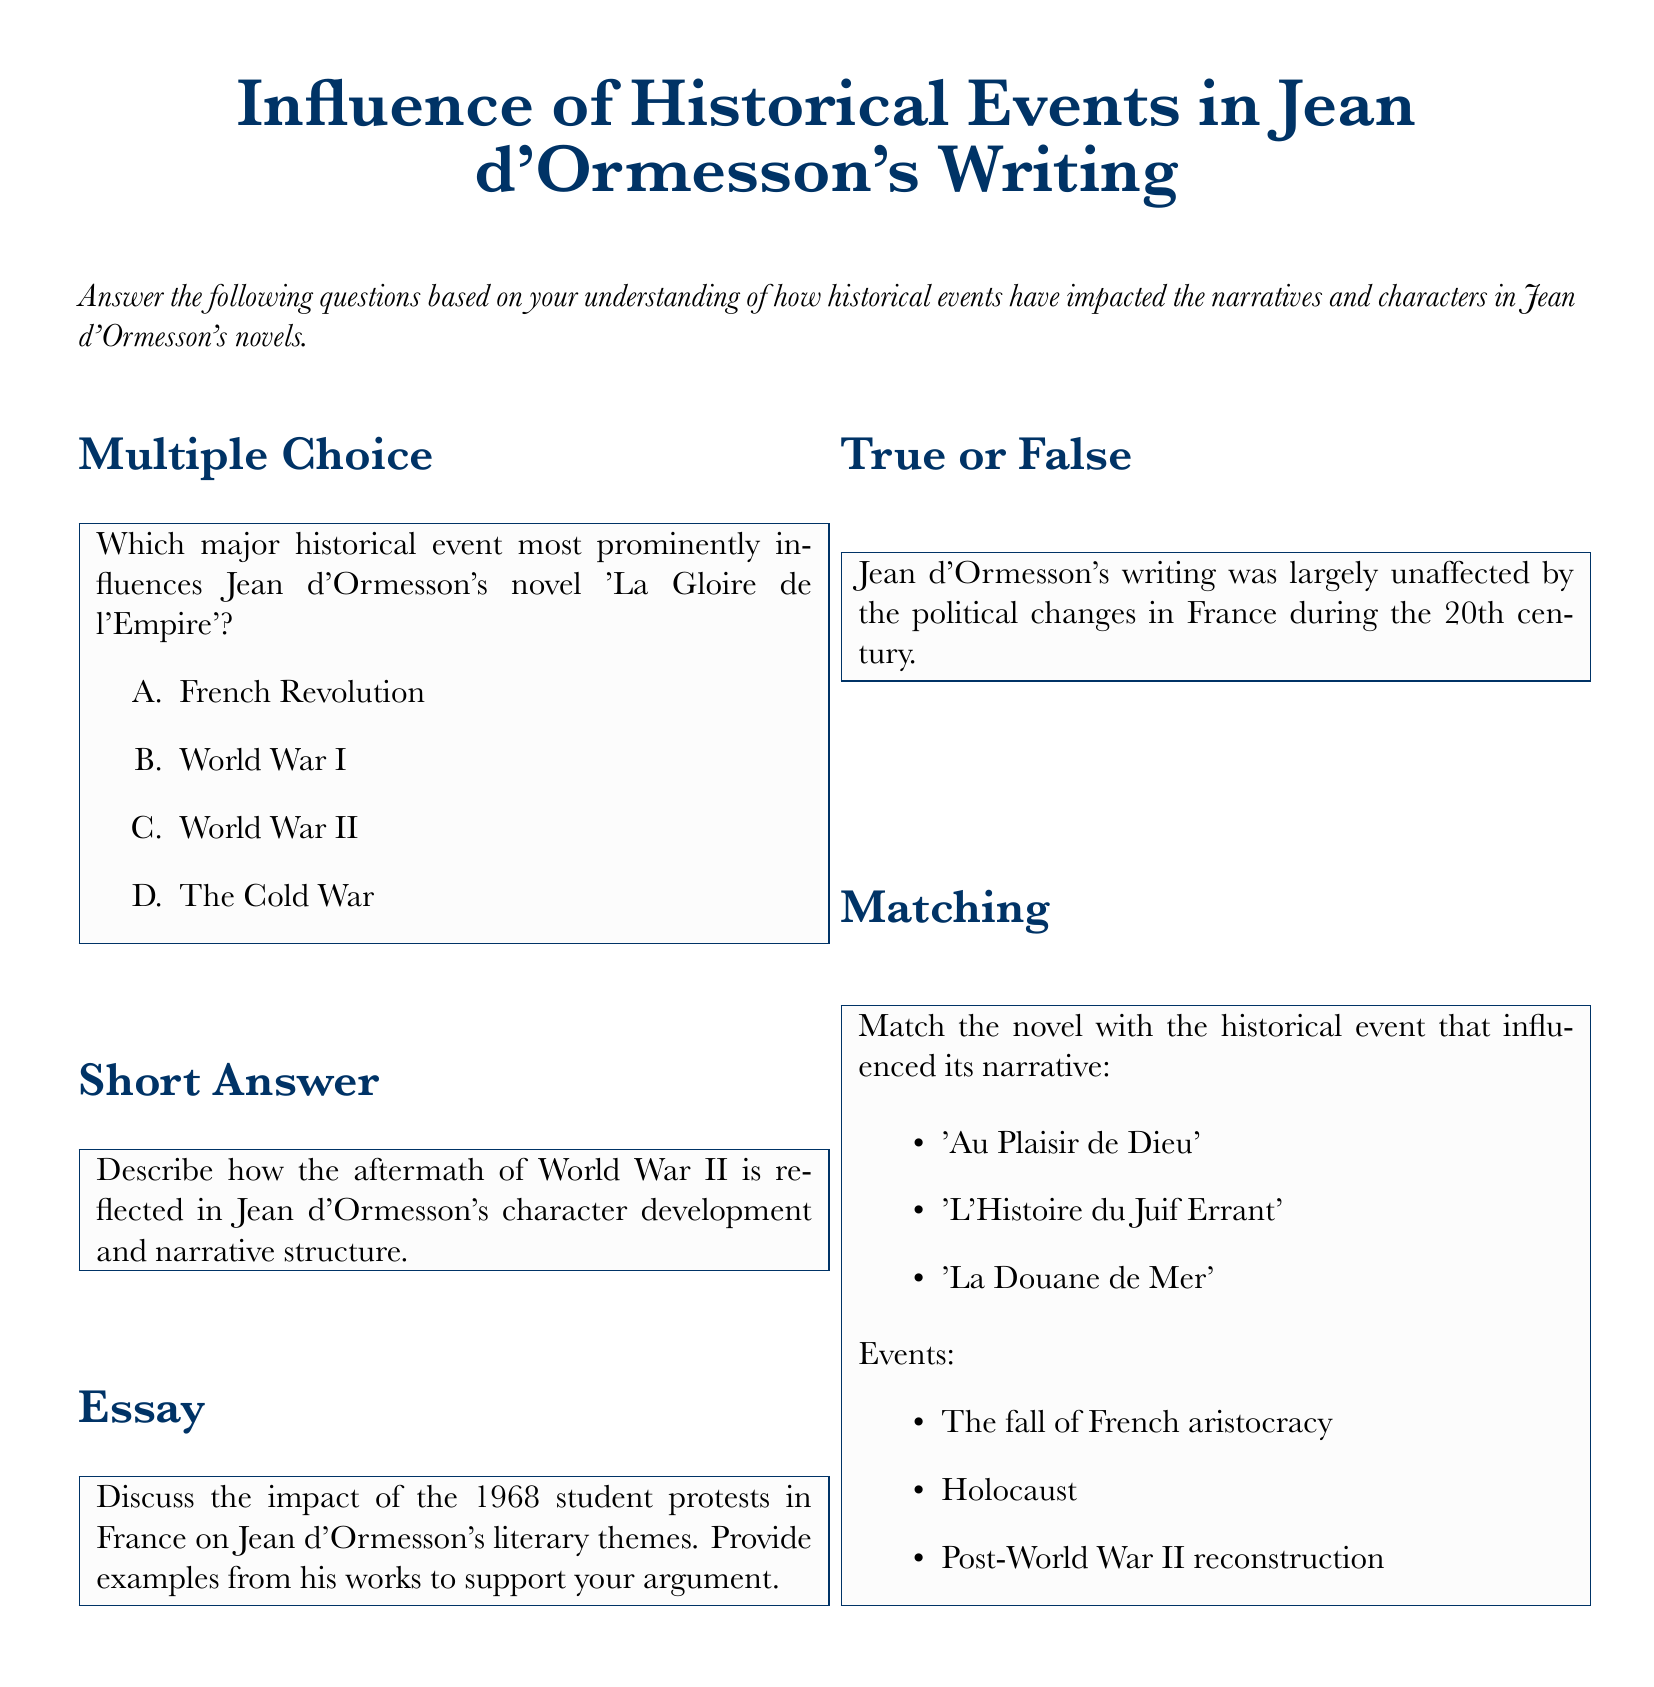What is the title of the document? The title of the document is prominently displayed in a large font at the top, stating the focus on the influence of historical events in Jean d'Ormesson's writing.
Answer: Influence of Historical Events in Jean d'Ormesson's Writing Which historical event is most prominently mentioned in the multiple-choice question? The multiple-choice question specifically asks about the major historical event influencing 'La Gloire de l'Empire', listing several options.
Answer: World War II How many types of questions are included in the document? The document encompasses different categories of questions, listed under multiple-choice, short answer, essay, true or false, and matching.
Answer: Five What is the subtitle of the short answer question section? The short answer section prompts to describe the aftermath of World War II's impact on character development and narrative structure.
Answer: Aftermath of World War II Which novel is matched with the Holocaust in the matching section? The matching section requires pairs to be assigned, specifically linking 'L'Histoire du Juif Errant' with a significant historical event.
Answer: L'Histoire du Juif Errant What is the focus of the essay question in the document? The essay question specifically addresses the impact of the 1968 student protests in France on Jean d'Ormesson's literary themes.
Answer: 1968 student protests How should the short answer questions be answered according to the document? The document emphasizes that short answer questions can be addressed using brief responses such as a single word, phrase, or number.
Answer: Brief responses Is the statement about Jean d'Ormesson's writing being unaffected by political changes true or false? The true or false question explicitly asks about the influence of political changes in France during the 20th century on his writing.
Answer: False 